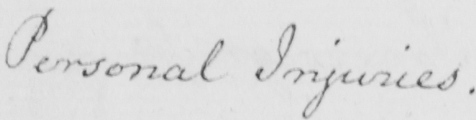Please transcribe the handwritten text in this image. Personal Injuries . 